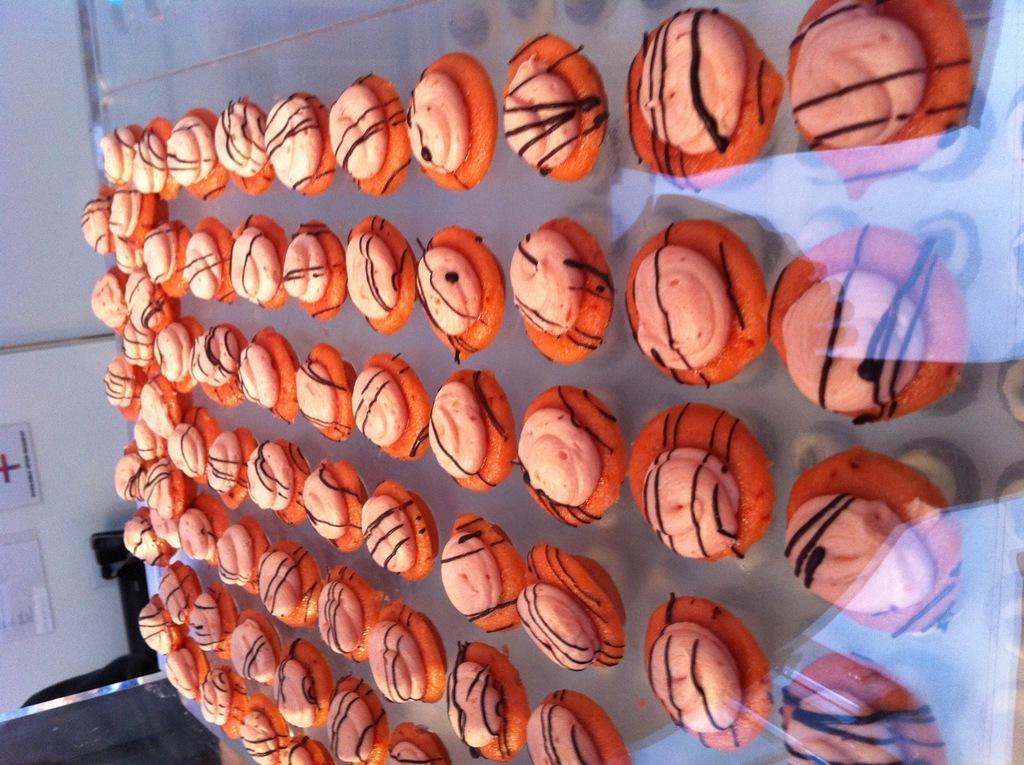Describe this image in one or two sentences. In this image we can see food items in a showcase. On the left side, we can see a wall. On the wall we can see few boards with text. 